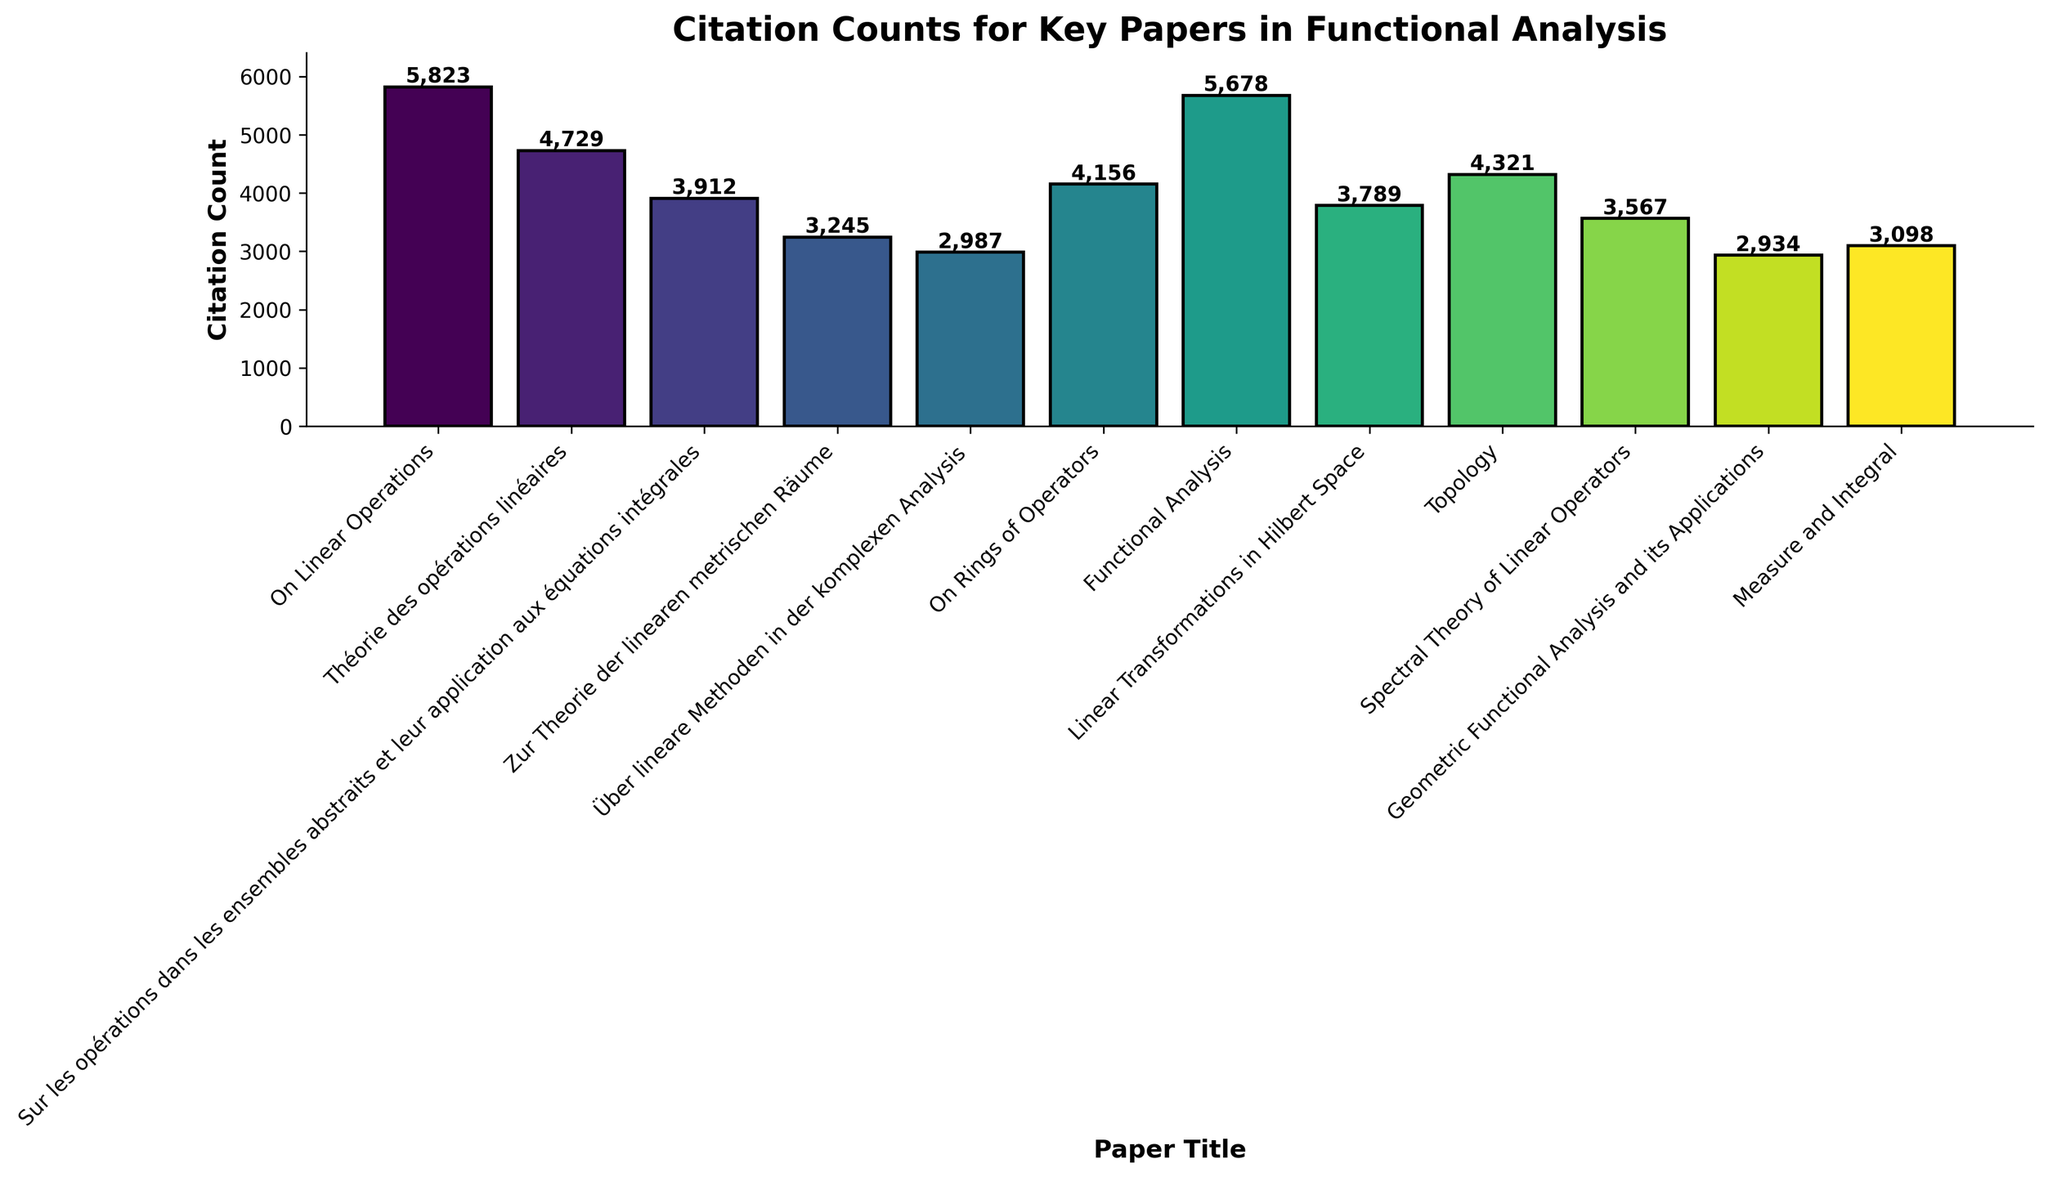Which paper has the highest citation count? To determine this, observe the heights of the bars in the bar chart. The tallest bar corresponds to the paper with the highest citation count.
Answer: "On Linear Operations" by Stefan Banach Which papers by Stefan Banach are featured, and what is their combined citation count? Locate the bars associated with papers authored by Stefan Banach and sum their citation counts.
Answer: 10,552 How much higher is the citation count of the most-cited paper compared to the least-cited paper? Identify the bars representing the most-cited and least-cited papers, then subtract the citation count of the least-cited paper from that of the most-cited paper. The most-cited paper has 5823 citations, and the least-cited has 2934 citations.
Answer: 2889 What is the average citation count of all the papers presented? Sum all the citation counts and then divide by the number of papers. (5823 + 4729 + 3912 + 3245 + 2987 + 4156 + 5678 + 3789 + 4321 + 3567 + 2934 + 3098) / 12 = 45,239 / 12 = 3769.92
Answer: 3769.92 Which two authors appear most frequently, and what are their respective total citation counts? Identify the frequency of appearance of each author and sum their citation counts. Stefan Banach appears most frequently (twice) with a total of 10,552 citations, and John von Neumann appears twice with a total of 7,254 citations.
Answer: Stefan Banach: 10,552; John von Neumann: 7,254 